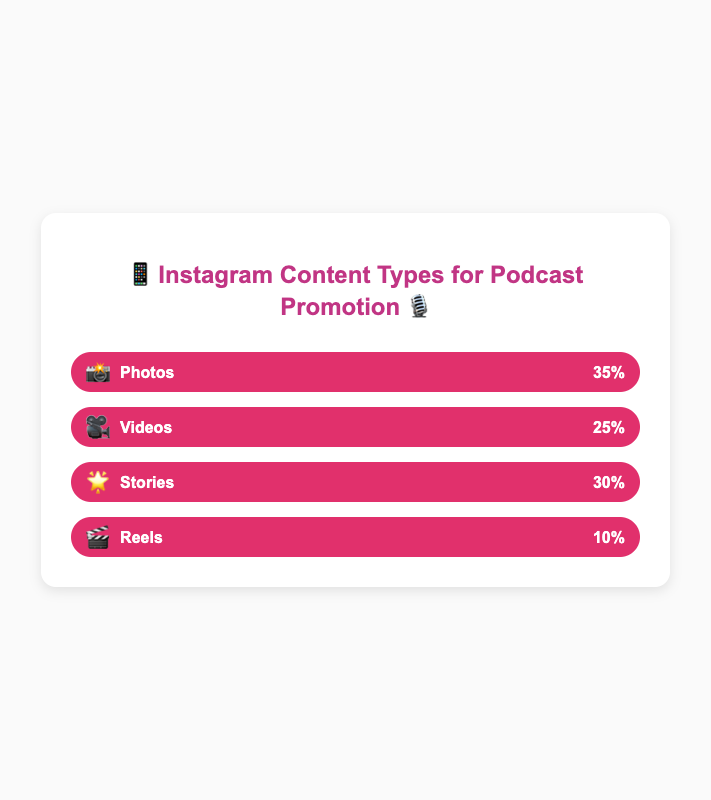What's the most common content type used in successful Instagram posts promoting podcasts? The bar representing "Photos" with a percentage of 35% is the largest, indicating it's the most common content type.
Answer: Photos 📸 Which content type appears second most frequently? The bar representing "Stories" with a percentage of 30% is the second-largest bar, indicating it is the second most common content type.
Answer: Stories 🌟 What's the least common content type used in successful Instagram posts promoting podcasts? The bar representing "Reels" with a percentage of 10% is the smallest, indicating it's the least common content type.
Answer: Reels 🎬 What is the combined percentage of Photos 📸 and Videos 🎥? The percentage for Photos is 35%, and for Videos, it is 25%. Summing them up gives 35% + 25% = 60%.
Answer: 60% How much more frequent are Stories 🌟 compared to Reels 🎬? The percentage for Stories is 30%, and for Reels, it is 10%. The difference is 30% - 10% = 20%.
Answer: 20% What is the total percentage of content types should be? Summing the percentages of all content types (Photos, Videos, Stories, Reels) gives 35% + 25% + 30% + 10% = 100%.
Answer: 100% Which two content types combined make up exactly the same percentage as Photos 📸? Videos have a percentage of 25% and Reels have 10%, together they add up to 25% + 10% = 35%, equal to Photos' percentage.
Answer: Videos 🎥 and Reels 🎬 Is there any content type contributing exactly one-third to the total percentage? One-third of 100% is approximately 33.33%. None of the bars have this exact percentage. The closest is Photos with 35%.
Answer: No What's the percentage difference between the most and least commonly used content types? The most common is Photos at 35%, and the least common is Reels at 10%. The difference is 35% - 10% = 25%.
Answer: 25% How many percentage points less than Stories 🌟 are Videos 🎥? Stories account for 30%, while Videos account for 25%. The difference is 30% - 25% = 5%.
Answer: 5% 